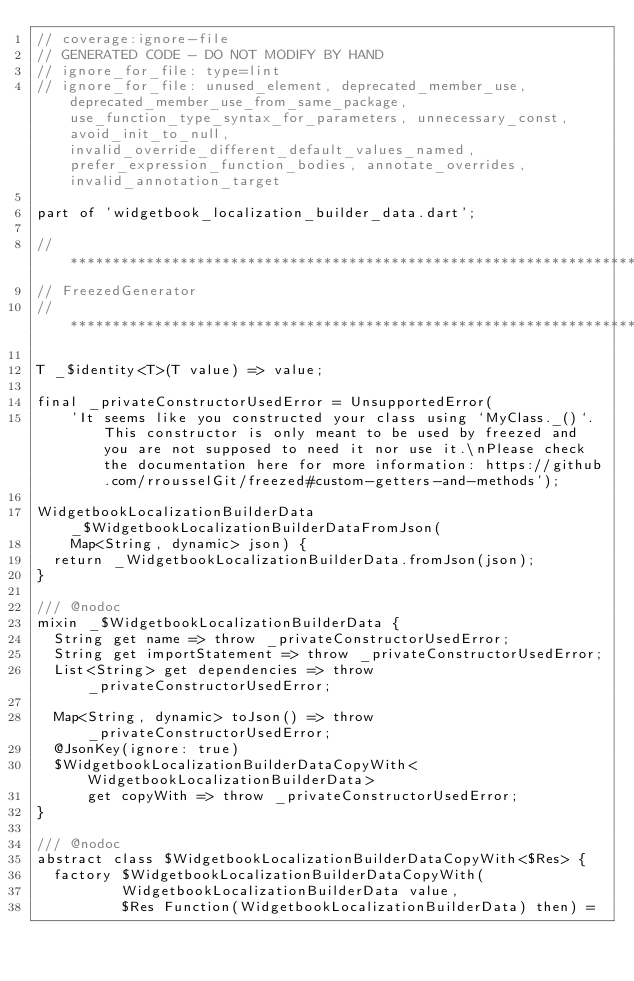<code> <loc_0><loc_0><loc_500><loc_500><_Dart_>// coverage:ignore-file
// GENERATED CODE - DO NOT MODIFY BY HAND
// ignore_for_file: type=lint
// ignore_for_file: unused_element, deprecated_member_use, deprecated_member_use_from_same_package, use_function_type_syntax_for_parameters, unnecessary_const, avoid_init_to_null, invalid_override_different_default_values_named, prefer_expression_function_bodies, annotate_overrides, invalid_annotation_target

part of 'widgetbook_localization_builder_data.dart';

// **************************************************************************
// FreezedGenerator
// **************************************************************************

T _$identity<T>(T value) => value;

final _privateConstructorUsedError = UnsupportedError(
    'It seems like you constructed your class using `MyClass._()`. This constructor is only meant to be used by freezed and you are not supposed to need it nor use it.\nPlease check the documentation here for more information: https://github.com/rrousselGit/freezed#custom-getters-and-methods');

WidgetbookLocalizationBuilderData _$WidgetbookLocalizationBuilderDataFromJson(
    Map<String, dynamic> json) {
  return _WidgetbookLocalizationBuilderData.fromJson(json);
}

/// @nodoc
mixin _$WidgetbookLocalizationBuilderData {
  String get name => throw _privateConstructorUsedError;
  String get importStatement => throw _privateConstructorUsedError;
  List<String> get dependencies => throw _privateConstructorUsedError;

  Map<String, dynamic> toJson() => throw _privateConstructorUsedError;
  @JsonKey(ignore: true)
  $WidgetbookLocalizationBuilderDataCopyWith<WidgetbookLocalizationBuilderData>
      get copyWith => throw _privateConstructorUsedError;
}

/// @nodoc
abstract class $WidgetbookLocalizationBuilderDataCopyWith<$Res> {
  factory $WidgetbookLocalizationBuilderDataCopyWith(
          WidgetbookLocalizationBuilderData value,
          $Res Function(WidgetbookLocalizationBuilderData) then) =</code> 